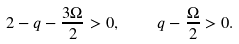Convert formula to latex. <formula><loc_0><loc_0><loc_500><loc_500>2 - q - \frac { 3 \Omega } { 2 } > 0 , \quad q - \frac { \Omega } { 2 } > 0 .</formula> 